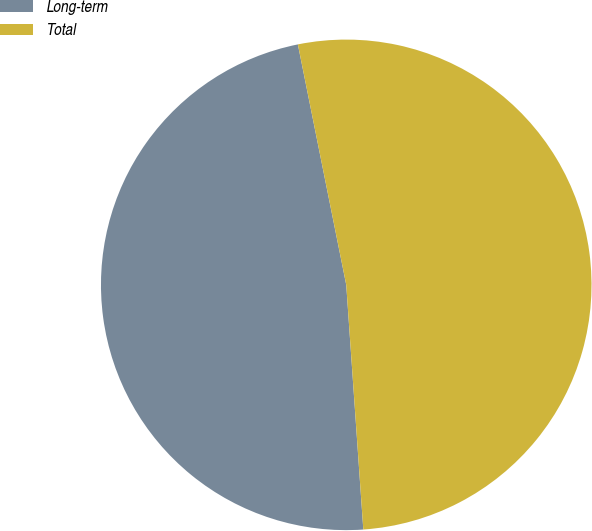Convert chart to OTSL. <chart><loc_0><loc_0><loc_500><loc_500><pie_chart><fcel>Long-term<fcel>Total<nl><fcel>47.95%<fcel>52.05%<nl></chart> 